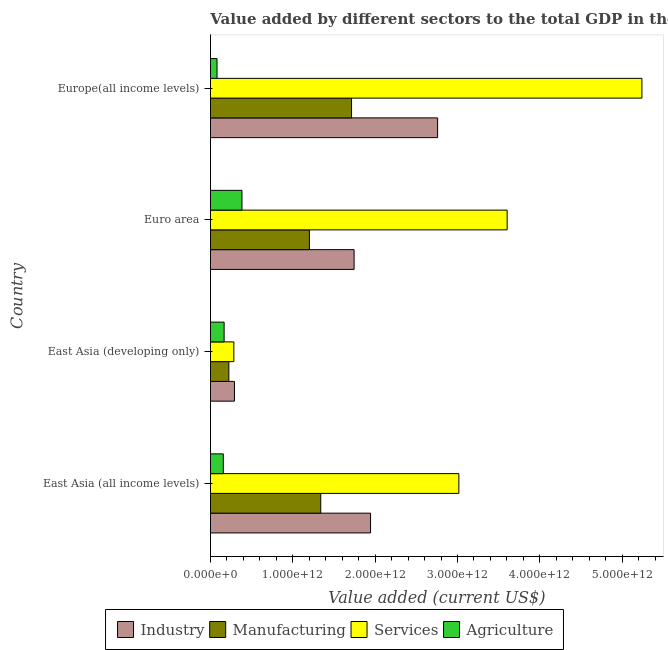Are the number of bars per tick equal to the number of legend labels?
Keep it short and to the point. Yes. How many bars are there on the 1st tick from the top?
Ensure brevity in your answer.  4. What is the label of the 1st group of bars from the top?
Keep it short and to the point. Europe(all income levels). What is the value added by industrial sector in Europe(all income levels)?
Your response must be concise. 2.76e+12. Across all countries, what is the maximum value added by agricultural sector?
Ensure brevity in your answer.  3.82e+11. Across all countries, what is the minimum value added by manufacturing sector?
Provide a short and direct response. 2.23e+11. In which country was the value added by industrial sector maximum?
Keep it short and to the point. Europe(all income levels). In which country was the value added by industrial sector minimum?
Your answer should be very brief. East Asia (developing only). What is the total value added by agricultural sector in the graph?
Keep it short and to the point. 7.84e+11. What is the difference between the value added by manufacturing sector in East Asia (developing only) and that in Euro area?
Ensure brevity in your answer.  -9.78e+11. What is the difference between the value added by manufacturing sector in Euro area and the value added by agricultural sector in East Asia (all income levels)?
Give a very brief answer. 1.05e+12. What is the average value added by agricultural sector per country?
Your answer should be compact. 1.96e+11. What is the difference between the value added by services sector and value added by industrial sector in Europe(all income levels)?
Ensure brevity in your answer.  2.48e+12. What is the ratio of the value added by agricultural sector in Euro area to that in Europe(all income levels)?
Provide a short and direct response. 4.8. What is the difference between the highest and the second highest value added by manufacturing sector?
Offer a terse response. 3.74e+11. What is the difference between the highest and the lowest value added by industrial sector?
Your response must be concise. 2.47e+12. Is the sum of the value added by agricultural sector in East Asia (all income levels) and Europe(all income levels) greater than the maximum value added by manufacturing sector across all countries?
Offer a terse response. No. Is it the case that in every country, the sum of the value added by agricultural sector and value added by industrial sector is greater than the sum of value added by services sector and value added by manufacturing sector?
Make the answer very short. No. What does the 2nd bar from the top in Euro area represents?
Offer a terse response. Services. What does the 3rd bar from the bottom in East Asia (developing only) represents?
Offer a terse response. Services. Is it the case that in every country, the sum of the value added by industrial sector and value added by manufacturing sector is greater than the value added by services sector?
Your answer should be very brief. No. How many bars are there?
Provide a succinct answer. 16. What is the difference between two consecutive major ticks on the X-axis?
Ensure brevity in your answer.  1.00e+12. Are the values on the major ticks of X-axis written in scientific E-notation?
Give a very brief answer. Yes. Where does the legend appear in the graph?
Your response must be concise. Bottom center. How are the legend labels stacked?
Provide a succinct answer. Horizontal. What is the title of the graph?
Offer a terse response. Value added by different sectors to the total GDP in the year 1991. Does "Iceland" appear as one of the legend labels in the graph?
Your answer should be very brief. No. What is the label or title of the X-axis?
Your response must be concise. Value added (current US$). What is the label or title of the Y-axis?
Give a very brief answer. Country. What is the Value added (current US$) of Industry in East Asia (all income levels)?
Keep it short and to the point. 1.94e+12. What is the Value added (current US$) in Manufacturing in East Asia (all income levels)?
Keep it short and to the point. 1.34e+12. What is the Value added (current US$) of Services in East Asia (all income levels)?
Give a very brief answer. 3.02e+12. What is the Value added (current US$) of Agriculture in East Asia (all income levels)?
Make the answer very short. 1.56e+11. What is the Value added (current US$) of Industry in East Asia (developing only)?
Make the answer very short. 2.91e+11. What is the Value added (current US$) in Manufacturing in East Asia (developing only)?
Offer a terse response. 2.23e+11. What is the Value added (current US$) of Services in East Asia (developing only)?
Provide a succinct answer. 2.84e+11. What is the Value added (current US$) in Agriculture in East Asia (developing only)?
Keep it short and to the point. 1.66e+11. What is the Value added (current US$) of Industry in Euro area?
Give a very brief answer. 1.74e+12. What is the Value added (current US$) in Manufacturing in Euro area?
Make the answer very short. 1.20e+12. What is the Value added (current US$) of Services in Euro area?
Offer a terse response. 3.60e+12. What is the Value added (current US$) in Agriculture in Euro area?
Offer a very short reply. 3.82e+11. What is the Value added (current US$) in Industry in Europe(all income levels)?
Your response must be concise. 2.76e+12. What is the Value added (current US$) of Manufacturing in Europe(all income levels)?
Provide a short and direct response. 1.71e+12. What is the Value added (current US$) in Services in Europe(all income levels)?
Ensure brevity in your answer.  5.24e+12. What is the Value added (current US$) of Agriculture in Europe(all income levels)?
Make the answer very short. 7.96e+1. Across all countries, what is the maximum Value added (current US$) in Industry?
Provide a succinct answer. 2.76e+12. Across all countries, what is the maximum Value added (current US$) of Manufacturing?
Your response must be concise. 1.71e+12. Across all countries, what is the maximum Value added (current US$) in Services?
Offer a very short reply. 5.24e+12. Across all countries, what is the maximum Value added (current US$) in Agriculture?
Your response must be concise. 3.82e+11. Across all countries, what is the minimum Value added (current US$) of Industry?
Provide a succinct answer. 2.91e+11. Across all countries, what is the minimum Value added (current US$) of Manufacturing?
Ensure brevity in your answer.  2.23e+11. Across all countries, what is the minimum Value added (current US$) of Services?
Your answer should be compact. 2.84e+11. Across all countries, what is the minimum Value added (current US$) in Agriculture?
Ensure brevity in your answer.  7.96e+1. What is the total Value added (current US$) in Industry in the graph?
Your answer should be compact. 6.74e+12. What is the total Value added (current US$) of Manufacturing in the graph?
Your answer should be very brief. 4.48e+12. What is the total Value added (current US$) of Services in the graph?
Offer a very short reply. 1.21e+13. What is the total Value added (current US$) of Agriculture in the graph?
Give a very brief answer. 7.84e+11. What is the difference between the Value added (current US$) in Industry in East Asia (all income levels) and that in East Asia (developing only)?
Offer a terse response. 1.65e+12. What is the difference between the Value added (current US$) of Manufacturing in East Asia (all income levels) and that in East Asia (developing only)?
Make the answer very short. 1.12e+12. What is the difference between the Value added (current US$) of Services in East Asia (all income levels) and that in East Asia (developing only)?
Your response must be concise. 2.73e+12. What is the difference between the Value added (current US$) of Agriculture in East Asia (all income levels) and that in East Asia (developing only)?
Offer a terse response. -1.01e+1. What is the difference between the Value added (current US$) in Industry in East Asia (all income levels) and that in Euro area?
Provide a short and direct response. 2.00e+11. What is the difference between the Value added (current US$) of Manufacturing in East Asia (all income levels) and that in Euro area?
Provide a short and direct response. 1.38e+11. What is the difference between the Value added (current US$) in Services in East Asia (all income levels) and that in Euro area?
Provide a succinct answer. -5.86e+11. What is the difference between the Value added (current US$) of Agriculture in East Asia (all income levels) and that in Euro area?
Make the answer very short. -2.27e+11. What is the difference between the Value added (current US$) of Industry in East Asia (all income levels) and that in Europe(all income levels)?
Your answer should be very brief. -8.14e+11. What is the difference between the Value added (current US$) of Manufacturing in East Asia (all income levels) and that in Europe(all income levels)?
Provide a short and direct response. -3.74e+11. What is the difference between the Value added (current US$) of Services in East Asia (all income levels) and that in Europe(all income levels)?
Offer a terse response. -2.22e+12. What is the difference between the Value added (current US$) in Agriculture in East Asia (all income levels) and that in Europe(all income levels)?
Your response must be concise. 7.61e+1. What is the difference between the Value added (current US$) in Industry in East Asia (developing only) and that in Euro area?
Offer a very short reply. -1.45e+12. What is the difference between the Value added (current US$) of Manufacturing in East Asia (developing only) and that in Euro area?
Give a very brief answer. -9.78e+11. What is the difference between the Value added (current US$) of Services in East Asia (developing only) and that in Euro area?
Keep it short and to the point. -3.32e+12. What is the difference between the Value added (current US$) in Agriculture in East Asia (developing only) and that in Euro area?
Provide a short and direct response. -2.17e+11. What is the difference between the Value added (current US$) of Industry in East Asia (developing only) and that in Europe(all income levels)?
Offer a very short reply. -2.47e+12. What is the difference between the Value added (current US$) in Manufacturing in East Asia (developing only) and that in Europe(all income levels)?
Provide a short and direct response. -1.49e+12. What is the difference between the Value added (current US$) of Services in East Asia (developing only) and that in Europe(all income levels)?
Your answer should be very brief. -4.96e+12. What is the difference between the Value added (current US$) of Agriculture in East Asia (developing only) and that in Europe(all income levels)?
Ensure brevity in your answer.  8.62e+1. What is the difference between the Value added (current US$) of Industry in Euro area and that in Europe(all income levels)?
Offer a very short reply. -1.01e+12. What is the difference between the Value added (current US$) in Manufacturing in Euro area and that in Europe(all income levels)?
Offer a very short reply. -5.12e+11. What is the difference between the Value added (current US$) in Services in Euro area and that in Europe(all income levels)?
Your answer should be compact. -1.64e+12. What is the difference between the Value added (current US$) in Agriculture in Euro area and that in Europe(all income levels)?
Keep it short and to the point. 3.03e+11. What is the difference between the Value added (current US$) of Industry in East Asia (all income levels) and the Value added (current US$) of Manufacturing in East Asia (developing only)?
Your response must be concise. 1.72e+12. What is the difference between the Value added (current US$) of Industry in East Asia (all income levels) and the Value added (current US$) of Services in East Asia (developing only)?
Offer a terse response. 1.66e+12. What is the difference between the Value added (current US$) of Industry in East Asia (all income levels) and the Value added (current US$) of Agriculture in East Asia (developing only)?
Keep it short and to the point. 1.78e+12. What is the difference between the Value added (current US$) of Manufacturing in East Asia (all income levels) and the Value added (current US$) of Services in East Asia (developing only)?
Provide a short and direct response. 1.06e+12. What is the difference between the Value added (current US$) in Manufacturing in East Asia (all income levels) and the Value added (current US$) in Agriculture in East Asia (developing only)?
Keep it short and to the point. 1.17e+12. What is the difference between the Value added (current US$) in Services in East Asia (all income levels) and the Value added (current US$) in Agriculture in East Asia (developing only)?
Your answer should be very brief. 2.85e+12. What is the difference between the Value added (current US$) in Industry in East Asia (all income levels) and the Value added (current US$) in Manufacturing in Euro area?
Provide a short and direct response. 7.43e+11. What is the difference between the Value added (current US$) in Industry in East Asia (all income levels) and the Value added (current US$) in Services in Euro area?
Make the answer very short. -1.66e+12. What is the difference between the Value added (current US$) in Industry in East Asia (all income levels) and the Value added (current US$) in Agriculture in Euro area?
Offer a very short reply. 1.56e+12. What is the difference between the Value added (current US$) of Manufacturing in East Asia (all income levels) and the Value added (current US$) of Services in Euro area?
Your answer should be very brief. -2.26e+12. What is the difference between the Value added (current US$) of Manufacturing in East Asia (all income levels) and the Value added (current US$) of Agriculture in Euro area?
Your answer should be very brief. 9.57e+11. What is the difference between the Value added (current US$) in Services in East Asia (all income levels) and the Value added (current US$) in Agriculture in Euro area?
Offer a terse response. 2.63e+12. What is the difference between the Value added (current US$) of Industry in East Asia (all income levels) and the Value added (current US$) of Manufacturing in Europe(all income levels)?
Ensure brevity in your answer.  2.30e+11. What is the difference between the Value added (current US$) in Industry in East Asia (all income levels) and the Value added (current US$) in Services in Europe(all income levels)?
Your response must be concise. -3.30e+12. What is the difference between the Value added (current US$) of Industry in East Asia (all income levels) and the Value added (current US$) of Agriculture in Europe(all income levels)?
Keep it short and to the point. 1.86e+12. What is the difference between the Value added (current US$) in Manufacturing in East Asia (all income levels) and the Value added (current US$) in Services in Europe(all income levels)?
Your answer should be very brief. -3.90e+12. What is the difference between the Value added (current US$) of Manufacturing in East Asia (all income levels) and the Value added (current US$) of Agriculture in Europe(all income levels)?
Provide a succinct answer. 1.26e+12. What is the difference between the Value added (current US$) in Services in East Asia (all income levels) and the Value added (current US$) in Agriculture in Europe(all income levels)?
Provide a succinct answer. 2.94e+12. What is the difference between the Value added (current US$) in Industry in East Asia (developing only) and the Value added (current US$) in Manufacturing in Euro area?
Provide a short and direct response. -9.10e+11. What is the difference between the Value added (current US$) of Industry in East Asia (developing only) and the Value added (current US$) of Services in Euro area?
Your response must be concise. -3.31e+12. What is the difference between the Value added (current US$) in Industry in East Asia (developing only) and the Value added (current US$) in Agriculture in Euro area?
Your answer should be very brief. -9.13e+1. What is the difference between the Value added (current US$) of Manufacturing in East Asia (developing only) and the Value added (current US$) of Services in Euro area?
Offer a terse response. -3.38e+12. What is the difference between the Value added (current US$) of Manufacturing in East Asia (developing only) and the Value added (current US$) of Agriculture in Euro area?
Provide a short and direct response. -1.59e+11. What is the difference between the Value added (current US$) in Services in East Asia (developing only) and the Value added (current US$) in Agriculture in Euro area?
Provide a short and direct response. -9.86e+1. What is the difference between the Value added (current US$) of Industry in East Asia (developing only) and the Value added (current US$) of Manufacturing in Europe(all income levels)?
Provide a succinct answer. -1.42e+12. What is the difference between the Value added (current US$) in Industry in East Asia (developing only) and the Value added (current US$) in Services in Europe(all income levels)?
Your answer should be very brief. -4.95e+12. What is the difference between the Value added (current US$) in Industry in East Asia (developing only) and the Value added (current US$) in Agriculture in Europe(all income levels)?
Offer a very short reply. 2.11e+11. What is the difference between the Value added (current US$) of Manufacturing in East Asia (developing only) and the Value added (current US$) of Services in Europe(all income levels)?
Offer a very short reply. -5.02e+12. What is the difference between the Value added (current US$) in Manufacturing in East Asia (developing only) and the Value added (current US$) in Agriculture in Europe(all income levels)?
Ensure brevity in your answer.  1.44e+11. What is the difference between the Value added (current US$) of Services in East Asia (developing only) and the Value added (current US$) of Agriculture in Europe(all income levels)?
Provide a short and direct response. 2.04e+11. What is the difference between the Value added (current US$) of Industry in Euro area and the Value added (current US$) of Manufacturing in Europe(all income levels)?
Make the answer very short. 3.09e+1. What is the difference between the Value added (current US$) of Industry in Euro area and the Value added (current US$) of Services in Europe(all income levels)?
Give a very brief answer. -3.50e+12. What is the difference between the Value added (current US$) in Industry in Euro area and the Value added (current US$) in Agriculture in Europe(all income levels)?
Offer a terse response. 1.66e+12. What is the difference between the Value added (current US$) in Manufacturing in Euro area and the Value added (current US$) in Services in Europe(all income levels)?
Keep it short and to the point. -4.04e+12. What is the difference between the Value added (current US$) in Manufacturing in Euro area and the Value added (current US$) in Agriculture in Europe(all income levels)?
Make the answer very short. 1.12e+12. What is the difference between the Value added (current US$) of Services in Euro area and the Value added (current US$) of Agriculture in Europe(all income levels)?
Offer a terse response. 3.52e+12. What is the average Value added (current US$) in Industry per country?
Offer a very short reply. 1.68e+12. What is the average Value added (current US$) in Manufacturing per country?
Your answer should be compact. 1.12e+12. What is the average Value added (current US$) in Services per country?
Your response must be concise. 3.04e+12. What is the average Value added (current US$) in Agriculture per country?
Give a very brief answer. 1.96e+11. What is the difference between the Value added (current US$) of Industry and Value added (current US$) of Manufacturing in East Asia (all income levels)?
Your response must be concise. 6.05e+11. What is the difference between the Value added (current US$) of Industry and Value added (current US$) of Services in East Asia (all income levels)?
Offer a very short reply. -1.07e+12. What is the difference between the Value added (current US$) of Industry and Value added (current US$) of Agriculture in East Asia (all income levels)?
Your response must be concise. 1.79e+12. What is the difference between the Value added (current US$) in Manufacturing and Value added (current US$) in Services in East Asia (all income levels)?
Your response must be concise. -1.68e+12. What is the difference between the Value added (current US$) in Manufacturing and Value added (current US$) in Agriculture in East Asia (all income levels)?
Give a very brief answer. 1.18e+12. What is the difference between the Value added (current US$) of Services and Value added (current US$) of Agriculture in East Asia (all income levels)?
Your answer should be very brief. 2.86e+12. What is the difference between the Value added (current US$) in Industry and Value added (current US$) in Manufacturing in East Asia (developing only)?
Ensure brevity in your answer.  6.79e+1. What is the difference between the Value added (current US$) of Industry and Value added (current US$) of Services in East Asia (developing only)?
Ensure brevity in your answer.  7.35e+09. What is the difference between the Value added (current US$) of Industry and Value added (current US$) of Agriculture in East Asia (developing only)?
Offer a terse response. 1.25e+11. What is the difference between the Value added (current US$) of Manufacturing and Value added (current US$) of Services in East Asia (developing only)?
Offer a terse response. -6.05e+1. What is the difference between the Value added (current US$) of Manufacturing and Value added (current US$) of Agriculture in East Asia (developing only)?
Your answer should be compact. 5.74e+1. What is the difference between the Value added (current US$) in Services and Value added (current US$) in Agriculture in East Asia (developing only)?
Your answer should be compact. 1.18e+11. What is the difference between the Value added (current US$) of Industry and Value added (current US$) of Manufacturing in Euro area?
Your answer should be compact. 5.43e+11. What is the difference between the Value added (current US$) of Industry and Value added (current US$) of Services in Euro area?
Provide a succinct answer. -1.86e+12. What is the difference between the Value added (current US$) of Industry and Value added (current US$) of Agriculture in Euro area?
Provide a short and direct response. 1.36e+12. What is the difference between the Value added (current US$) in Manufacturing and Value added (current US$) in Services in Euro area?
Your answer should be compact. -2.40e+12. What is the difference between the Value added (current US$) in Manufacturing and Value added (current US$) in Agriculture in Euro area?
Give a very brief answer. 8.19e+11. What is the difference between the Value added (current US$) of Services and Value added (current US$) of Agriculture in Euro area?
Keep it short and to the point. 3.22e+12. What is the difference between the Value added (current US$) in Industry and Value added (current US$) in Manufacturing in Europe(all income levels)?
Your answer should be very brief. 1.04e+12. What is the difference between the Value added (current US$) of Industry and Value added (current US$) of Services in Europe(all income levels)?
Offer a terse response. -2.48e+12. What is the difference between the Value added (current US$) in Industry and Value added (current US$) in Agriculture in Europe(all income levels)?
Your answer should be compact. 2.68e+12. What is the difference between the Value added (current US$) of Manufacturing and Value added (current US$) of Services in Europe(all income levels)?
Make the answer very short. -3.53e+12. What is the difference between the Value added (current US$) of Manufacturing and Value added (current US$) of Agriculture in Europe(all income levels)?
Your answer should be very brief. 1.63e+12. What is the difference between the Value added (current US$) in Services and Value added (current US$) in Agriculture in Europe(all income levels)?
Provide a short and direct response. 5.16e+12. What is the ratio of the Value added (current US$) in Industry in East Asia (all income levels) to that in East Asia (developing only)?
Keep it short and to the point. 6.68. What is the ratio of the Value added (current US$) of Manufacturing in East Asia (all income levels) to that in East Asia (developing only)?
Ensure brevity in your answer.  6. What is the ratio of the Value added (current US$) in Services in East Asia (all income levels) to that in East Asia (developing only)?
Provide a short and direct response. 10.63. What is the ratio of the Value added (current US$) of Agriculture in East Asia (all income levels) to that in East Asia (developing only)?
Offer a terse response. 0.94. What is the ratio of the Value added (current US$) of Industry in East Asia (all income levels) to that in Euro area?
Ensure brevity in your answer.  1.11. What is the ratio of the Value added (current US$) of Manufacturing in East Asia (all income levels) to that in Euro area?
Ensure brevity in your answer.  1.11. What is the ratio of the Value added (current US$) in Services in East Asia (all income levels) to that in Euro area?
Offer a very short reply. 0.84. What is the ratio of the Value added (current US$) of Agriculture in East Asia (all income levels) to that in Euro area?
Provide a succinct answer. 0.41. What is the ratio of the Value added (current US$) of Industry in East Asia (all income levels) to that in Europe(all income levels)?
Offer a very short reply. 0.7. What is the ratio of the Value added (current US$) in Manufacturing in East Asia (all income levels) to that in Europe(all income levels)?
Make the answer very short. 0.78. What is the ratio of the Value added (current US$) of Services in East Asia (all income levels) to that in Europe(all income levels)?
Make the answer very short. 0.58. What is the ratio of the Value added (current US$) in Agriculture in East Asia (all income levels) to that in Europe(all income levels)?
Your answer should be compact. 1.96. What is the ratio of the Value added (current US$) in Industry in East Asia (developing only) to that in Euro area?
Offer a terse response. 0.17. What is the ratio of the Value added (current US$) of Manufacturing in East Asia (developing only) to that in Euro area?
Make the answer very short. 0.19. What is the ratio of the Value added (current US$) of Services in East Asia (developing only) to that in Euro area?
Make the answer very short. 0.08. What is the ratio of the Value added (current US$) of Agriculture in East Asia (developing only) to that in Euro area?
Offer a terse response. 0.43. What is the ratio of the Value added (current US$) of Industry in East Asia (developing only) to that in Europe(all income levels)?
Provide a succinct answer. 0.11. What is the ratio of the Value added (current US$) in Manufacturing in East Asia (developing only) to that in Europe(all income levels)?
Your answer should be very brief. 0.13. What is the ratio of the Value added (current US$) in Services in East Asia (developing only) to that in Europe(all income levels)?
Your response must be concise. 0.05. What is the ratio of the Value added (current US$) in Agriculture in East Asia (developing only) to that in Europe(all income levels)?
Keep it short and to the point. 2.08. What is the ratio of the Value added (current US$) in Industry in Euro area to that in Europe(all income levels)?
Offer a very short reply. 0.63. What is the ratio of the Value added (current US$) in Manufacturing in Euro area to that in Europe(all income levels)?
Your response must be concise. 0.7. What is the ratio of the Value added (current US$) of Services in Euro area to that in Europe(all income levels)?
Give a very brief answer. 0.69. What is the ratio of the Value added (current US$) in Agriculture in Euro area to that in Europe(all income levels)?
Keep it short and to the point. 4.8. What is the difference between the highest and the second highest Value added (current US$) in Industry?
Give a very brief answer. 8.14e+11. What is the difference between the highest and the second highest Value added (current US$) in Manufacturing?
Your response must be concise. 3.74e+11. What is the difference between the highest and the second highest Value added (current US$) of Services?
Provide a succinct answer. 1.64e+12. What is the difference between the highest and the second highest Value added (current US$) in Agriculture?
Provide a succinct answer. 2.17e+11. What is the difference between the highest and the lowest Value added (current US$) of Industry?
Keep it short and to the point. 2.47e+12. What is the difference between the highest and the lowest Value added (current US$) in Manufacturing?
Offer a terse response. 1.49e+12. What is the difference between the highest and the lowest Value added (current US$) in Services?
Provide a succinct answer. 4.96e+12. What is the difference between the highest and the lowest Value added (current US$) in Agriculture?
Offer a terse response. 3.03e+11. 